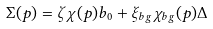Convert formula to latex. <formula><loc_0><loc_0><loc_500><loc_500>\Sigma ( p ) = \zeta \chi ( p ) b _ { 0 } + \xi _ { b g } \chi _ { b g } ( p ) \Delta</formula> 